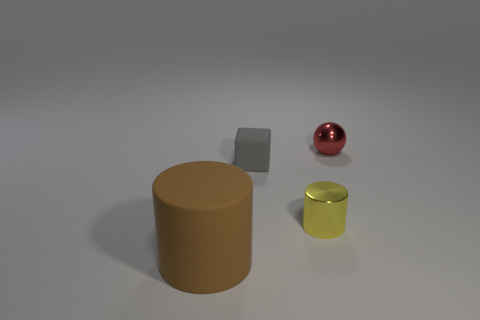Subtract all balls. How many objects are left? 3 Add 4 cyan objects. How many objects exist? 8 Subtract all yellow cylinders. How many cylinders are left? 1 Add 1 gray balls. How many gray balls exist? 1 Subtract 0 red cylinders. How many objects are left? 4 Subtract 1 spheres. How many spheres are left? 0 Subtract all blue spheres. Subtract all cyan cylinders. How many spheres are left? 1 Subtract all blue blocks. How many brown cylinders are left? 1 Subtract all tiny purple matte cylinders. Subtract all yellow metallic objects. How many objects are left? 3 Add 4 small matte objects. How many small matte objects are left? 5 